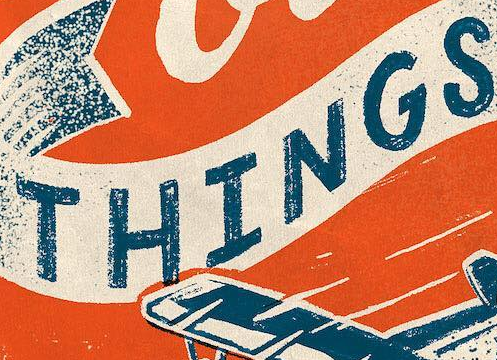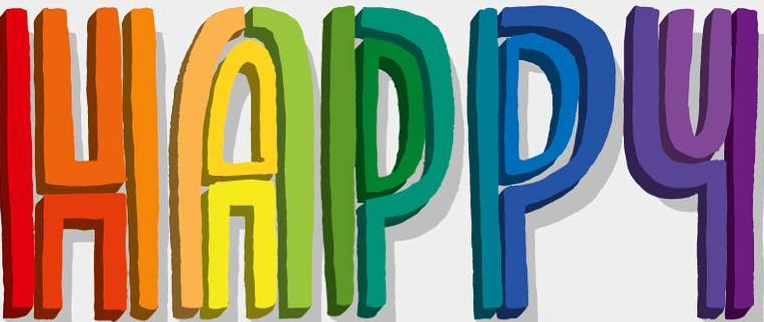Transcribe the words shown in these images in order, separated by a semicolon. THINGS; HAPPY 